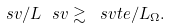Convert formula to latex. <formula><loc_0><loc_0><loc_500><loc_500>\ s v / L _ { \ } s v \gtrsim \ s v t e / L _ { \Omega } .</formula> 